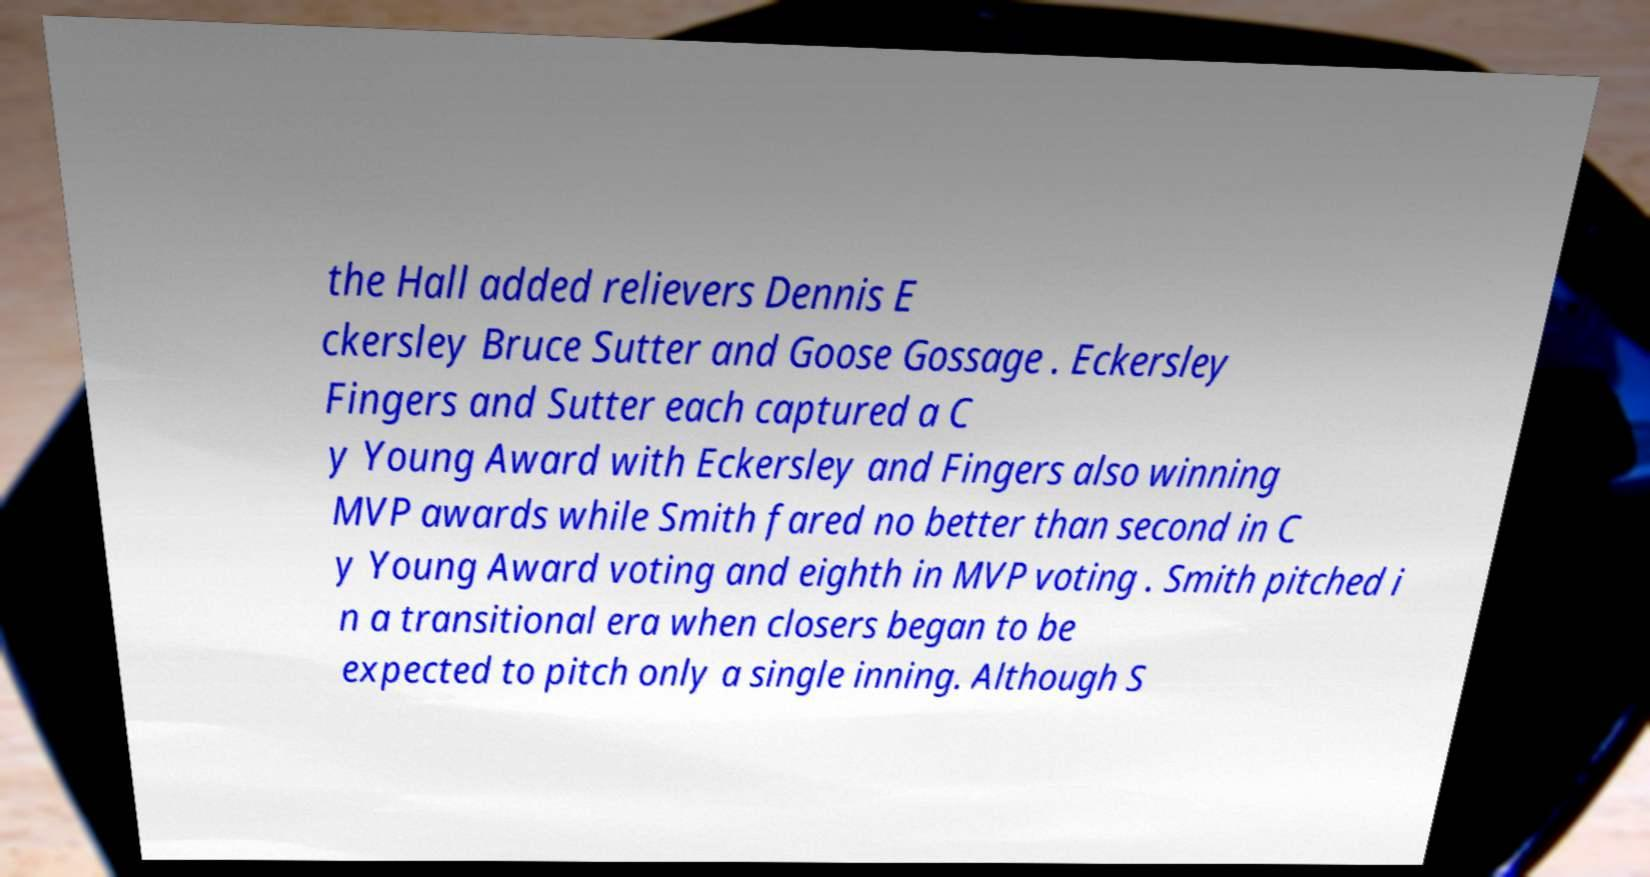What messages or text are displayed in this image? I need them in a readable, typed format. the Hall added relievers Dennis E ckersley Bruce Sutter and Goose Gossage . Eckersley Fingers and Sutter each captured a C y Young Award with Eckersley and Fingers also winning MVP awards while Smith fared no better than second in C y Young Award voting and eighth in MVP voting . Smith pitched i n a transitional era when closers began to be expected to pitch only a single inning. Although S 